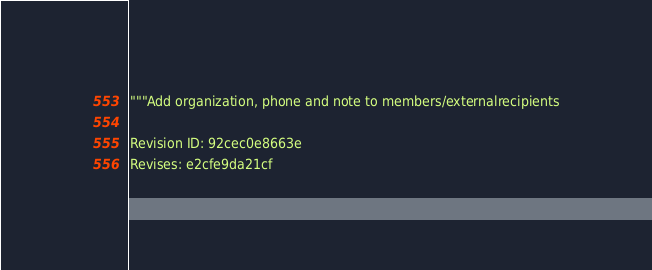<code> <loc_0><loc_0><loc_500><loc_500><_Python_>"""Add organization, phone and note to members/externalrecipients

Revision ID: 92cec0e8663e
Revises: e2cfe9da21cf</code> 